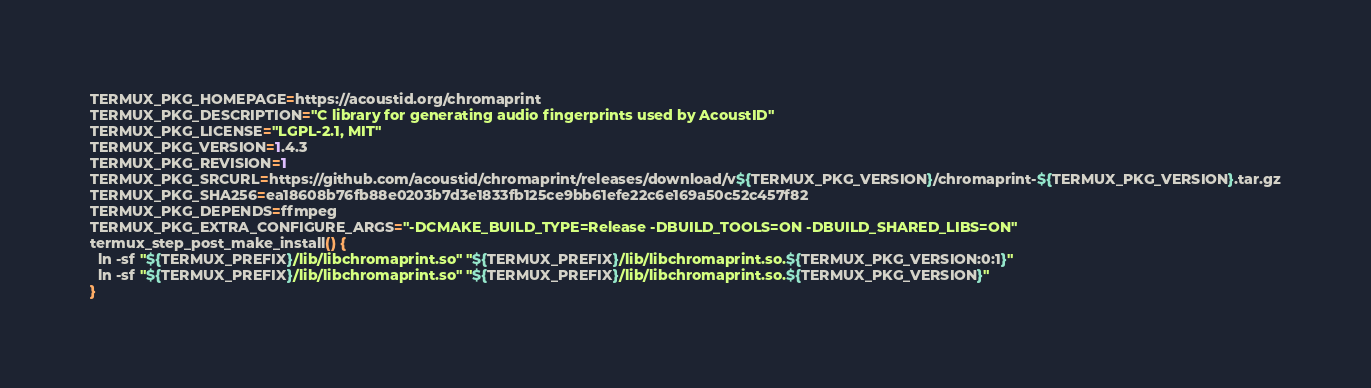<code> <loc_0><loc_0><loc_500><loc_500><_Bash_>TERMUX_PKG_HOMEPAGE=https://acoustid.org/chromaprint
TERMUX_PKG_DESCRIPTION="C library for generating audio fingerprints used by AcoustID"
TERMUX_PKG_LICENSE="LGPL-2.1, MIT"
TERMUX_PKG_VERSION=1.4.3
TERMUX_PKG_REVISION=1
TERMUX_PKG_SRCURL=https://github.com/acoustid/chromaprint/releases/download/v${TERMUX_PKG_VERSION}/chromaprint-${TERMUX_PKG_VERSION}.tar.gz
TERMUX_PKG_SHA256=ea18608b76fb88e0203b7d3e1833fb125ce9bb61efe22c6e169a50c52c457f82
TERMUX_PKG_DEPENDS=ffmpeg
TERMUX_PKG_EXTRA_CONFIGURE_ARGS="-DCMAKE_BUILD_TYPE=Release -DBUILD_TOOLS=ON -DBUILD_SHARED_LIBS=ON"
termux_step_post_make_install() {
  ln -sf "${TERMUX_PREFIX}/lib/libchromaprint.so" "${TERMUX_PREFIX}/lib/libchromaprint.so.${TERMUX_PKG_VERSION:0:1}"
  ln -sf "${TERMUX_PREFIX}/lib/libchromaprint.so" "${TERMUX_PREFIX}/lib/libchromaprint.so.${TERMUX_PKG_VERSION}"
}
</code> 